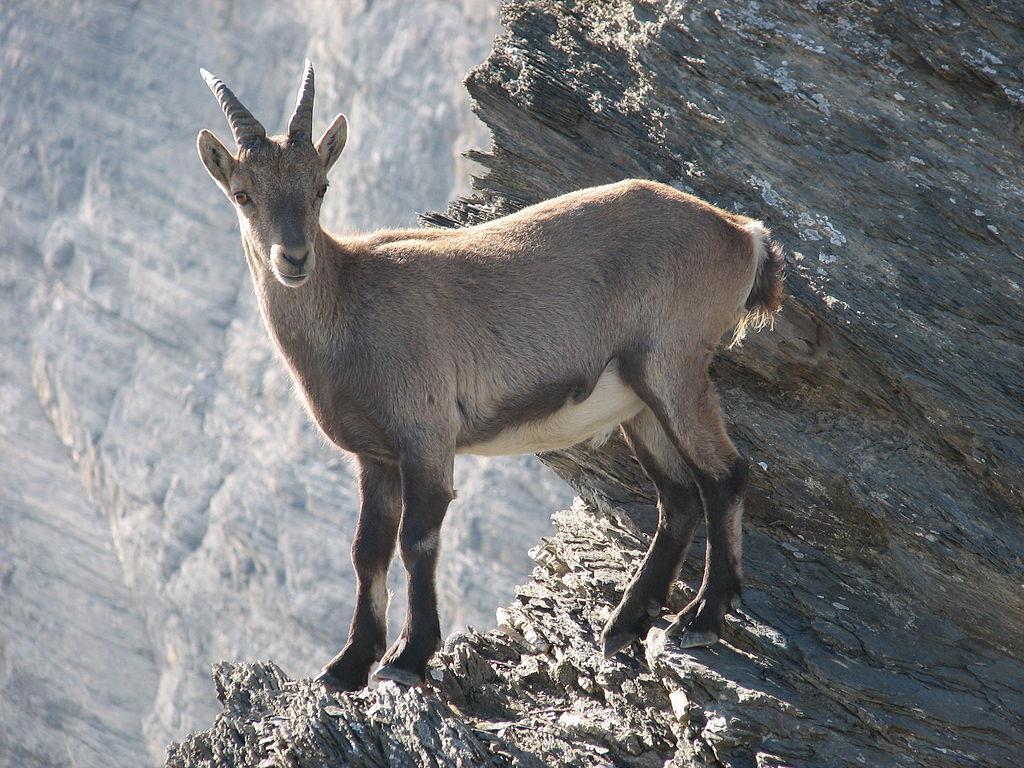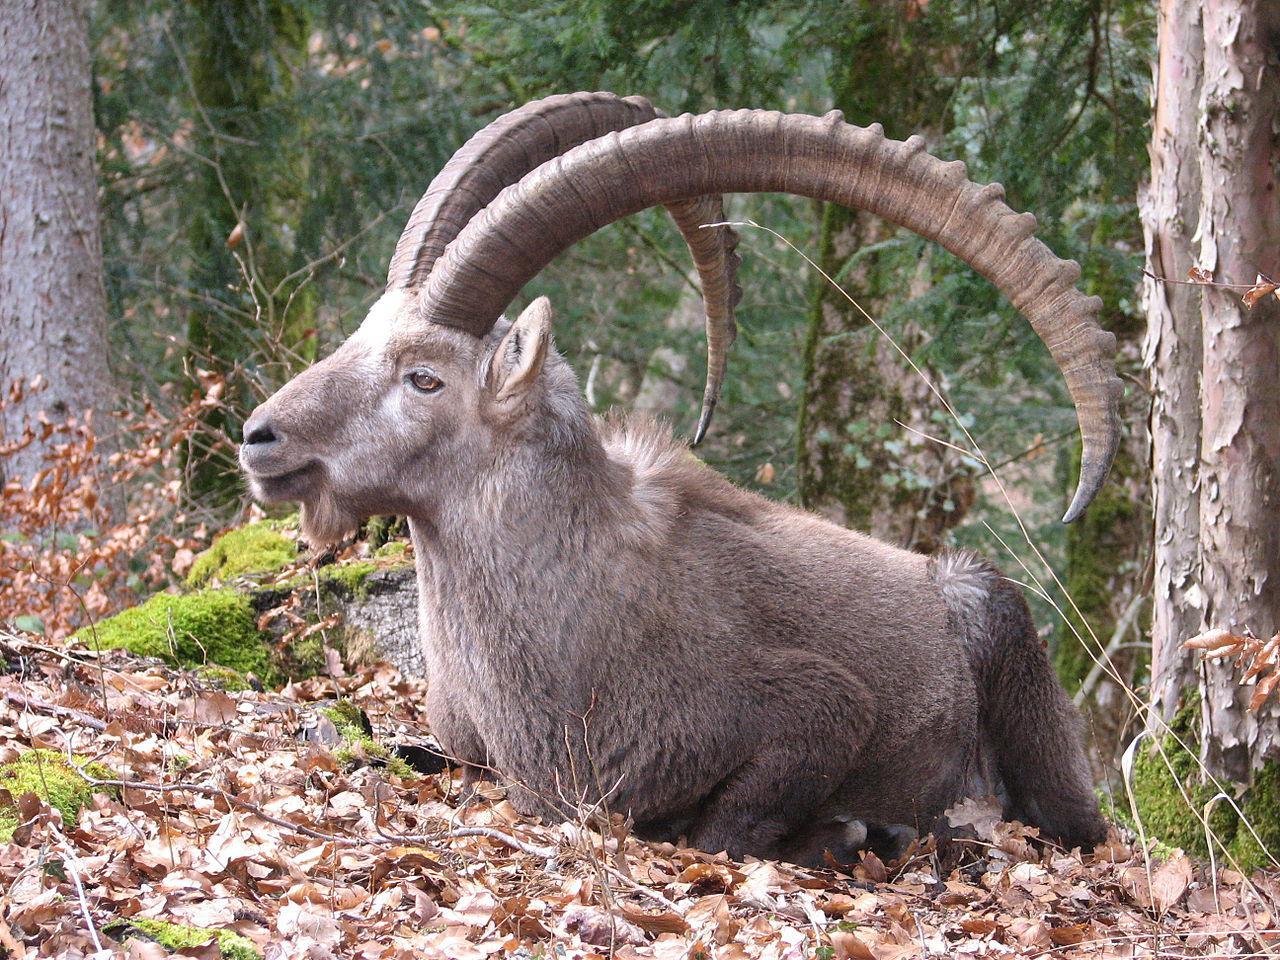The first image is the image on the left, the second image is the image on the right. Considering the images on both sides, is "both animals are facing the same direction." valid? Answer yes or no. Yes. 